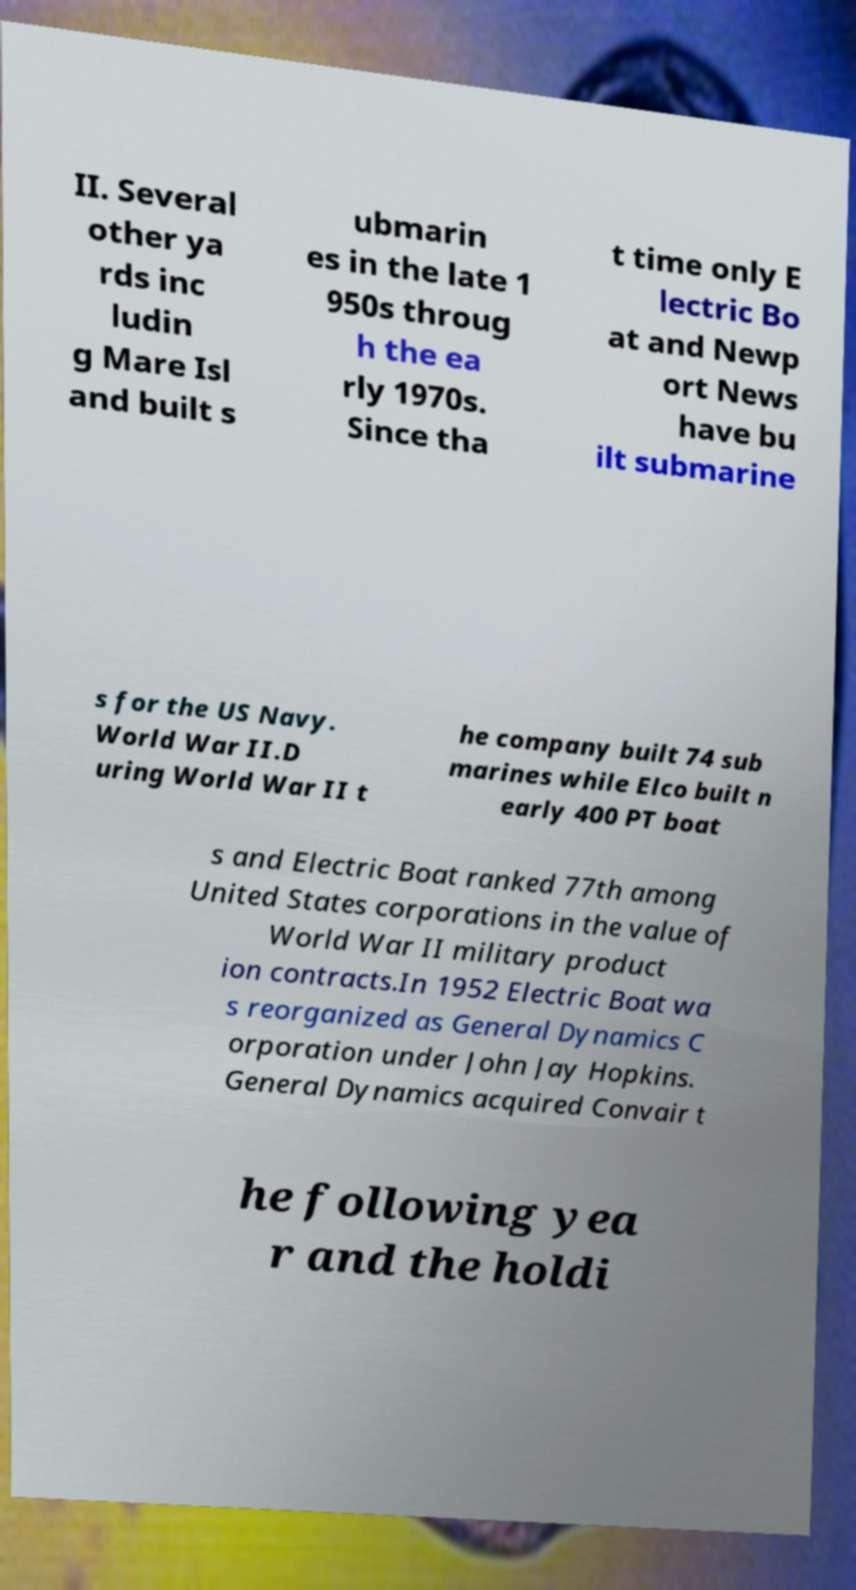I need the written content from this picture converted into text. Can you do that? II. Several other ya rds inc ludin g Mare Isl and built s ubmarin es in the late 1 950s throug h the ea rly 1970s. Since tha t time only E lectric Bo at and Newp ort News have bu ilt submarine s for the US Navy. World War II.D uring World War II t he company built 74 sub marines while Elco built n early 400 PT boat s and Electric Boat ranked 77th among United States corporations in the value of World War II military product ion contracts.In 1952 Electric Boat wa s reorganized as General Dynamics C orporation under John Jay Hopkins. General Dynamics acquired Convair t he following yea r and the holdi 